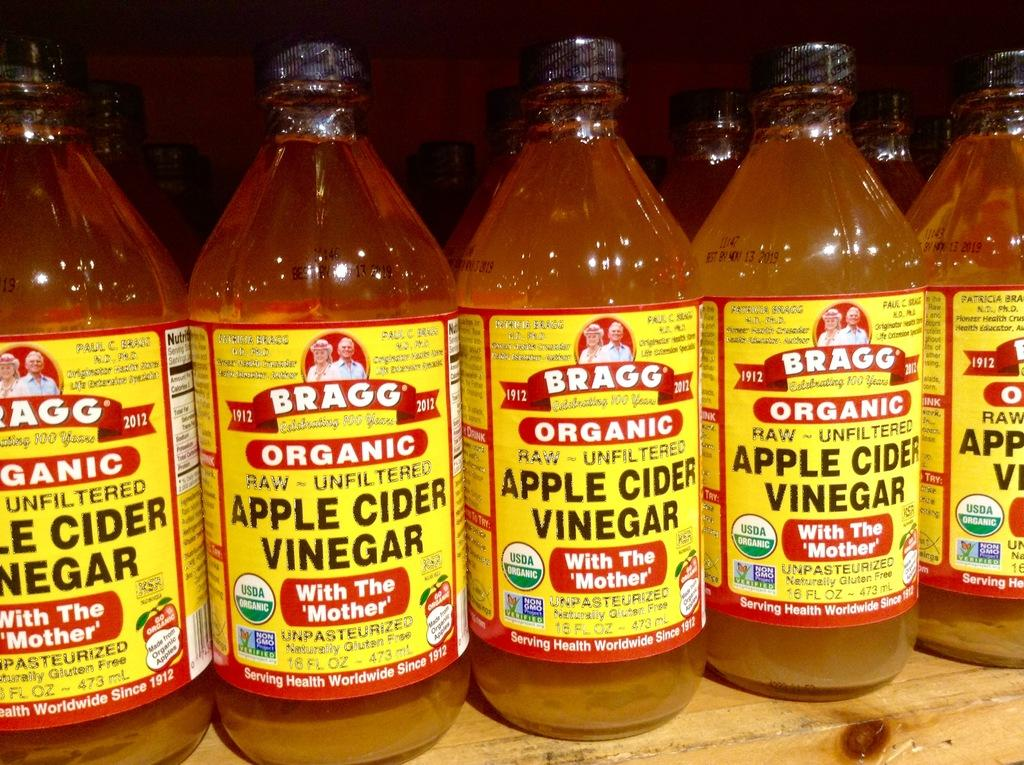<image>
Render a clear and concise summary of the photo. A bunch of bottles of Apple Cider Vinegar lined up on a shelf. 